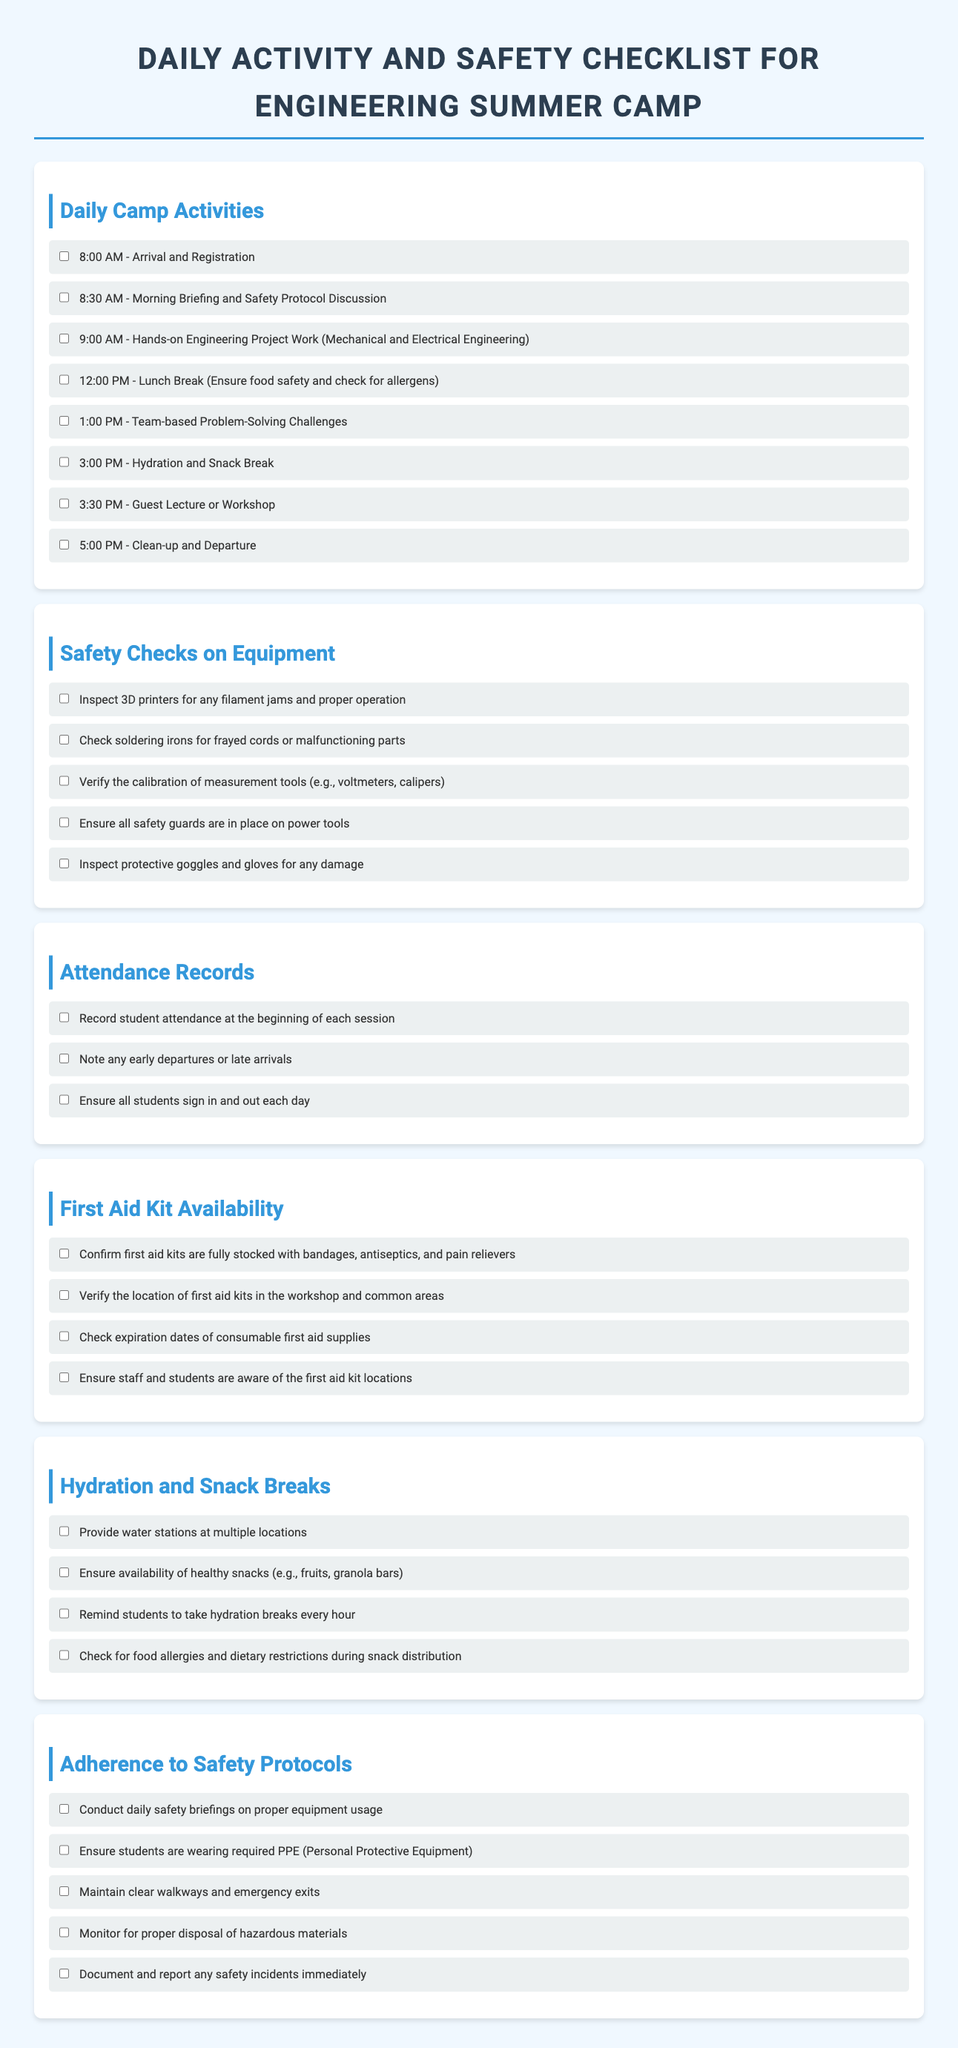What time does the morning briefing start? The morning briefing starts at 8:30 AM, as listed in the daily camp activities section.
Answer: 8:30 AM How many items are checked under safety checks on equipment? There are five items listed under safety checks on equipment, requiring verification for safe operation.
Answer: Five What should students do during the 3:00 PM break? During the 3:00 PM break, students are reminded to hydrate and have a snack.
Answer: Hydrate and snack What items need to be stocked in the first aid kit? The first aid kit should be stocked with bandages, antiseptics, and pain relievers, as mentioned in the availability section.
Answer: Bandages, antiseptics, and pain relievers How often should students take hydration breaks? Students should take hydration breaks every hour, as stated in the hydration and snack breaks section.
Answer: Every hour What is the first activity listed for the camp day? The first activity listed for the camp day is Arrival and Registration at 8:00 AM.
Answer: Arrival and Registration What are students required to wear according to safety protocols? According to safety protocols, students are required to wear Personal Protective Equipment (PPE).
Answer: Personal Protective Equipment (PPE) What should be checked for food allergies during snack distribution? Food allergies and dietary restrictions should be checked during snack distribution.
Answer: Food allergies and dietary restrictions 